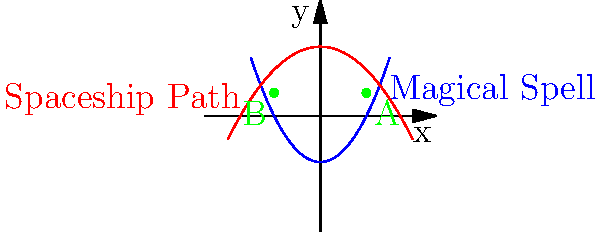In the coordinate plane above, the blue curve represents the trajectory of a magical spell, described by the equation $y = 0.5x^2 - 2$, while the red curve shows a spaceship's flight path, given by $y = -0.25x^2 + 3$. At which points do the magical spell and the spaceship's path intersect, and what is the total distance between these intersection points? To solve this problem, we'll follow these steps:

1) Find the intersection points by equating the two functions:
   $0.5x^2 - 2 = -0.25x^2 + 3$

2) Simplify the equation:
   $0.75x^2 = 5$
   $x^2 = \frac{20}{3}$

3) Solve for x:
   $x = \pm \sqrt{\frac{20}{3}} \approx \pm 2.58$

4) The exact x-coordinates of the intersection points are $-\sqrt{\frac{20}{3}}$ and $\sqrt{\frac{20}{3}}$.

5) To find the y-coordinate, substitute either x value into either equation:
   $y = 0.5(\sqrt{\frac{20}{3}})^2 - 2 = \frac{10}{3} - 2 = \frac{4}{3} \approx 1.33$

6) The intersection points are approximately (-2.58, 1.33) and (2.58, 1.33).

7) The distance between these points is the absolute difference of their x-coordinates:
   $|\sqrt{\frac{20}{3}} - (-\sqrt{\frac{20}{3}})| = 2\sqrt{\frac{20}{3}}$

Therefore, the total distance between the intersection points is $2\sqrt{\frac{20}{3}}$.
Answer: $2\sqrt{\frac{20}{3}}$ 